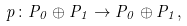Convert formula to latex. <formula><loc_0><loc_0><loc_500><loc_500>p \colon P _ { 0 } \oplus P _ { 1 } \to P _ { 0 } \oplus P _ { 1 } ,</formula> 